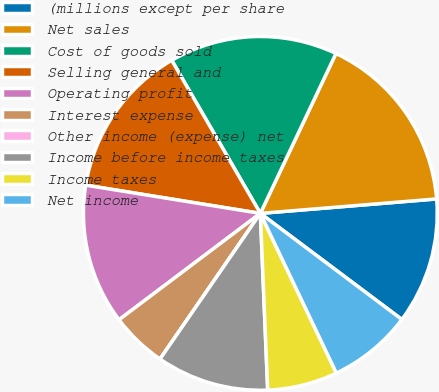Convert chart. <chart><loc_0><loc_0><loc_500><loc_500><pie_chart><fcel>(millions except per share<fcel>Net sales<fcel>Cost of goods sold<fcel>Selling general and<fcel>Operating profit<fcel>Interest expense<fcel>Other income (expense) net<fcel>Income before income taxes<fcel>Income taxes<fcel>Net income<nl><fcel>11.54%<fcel>16.67%<fcel>15.38%<fcel>14.1%<fcel>12.82%<fcel>5.13%<fcel>0.0%<fcel>10.26%<fcel>6.41%<fcel>7.69%<nl></chart> 